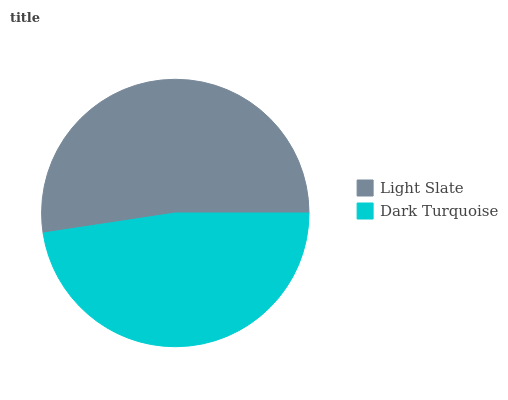Is Dark Turquoise the minimum?
Answer yes or no. Yes. Is Light Slate the maximum?
Answer yes or no. Yes. Is Dark Turquoise the maximum?
Answer yes or no. No. Is Light Slate greater than Dark Turquoise?
Answer yes or no. Yes. Is Dark Turquoise less than Light Slate?
Answer yes or no. Yes. Is Dark Turquoise greater than Light Slate?
Answer yes or no. No. Is Light Slate less than Dark Turquoise?
Answer yes or no. No. Is Light Slate the high median?
Answer yes or no. Yes. Is Dark Turquoise the low median?
Answer yes or no. Yes. Is Dark Turquoise the high median?
Answer yes or no. No. Is Light Slate the low median?
Answer yes or no. No. 